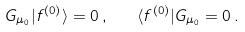Convert formula to latex. <formula><loc_0><loc_0><loc_500><loc_500>G _ { \mu _ { 0 } } | f ^ { ( 0 ) } \rangle = 0 \, , \quad \langle f ^ { ( 0 ) } | G _ { \mu _ { 0 } } = 0 \, .</formula> 